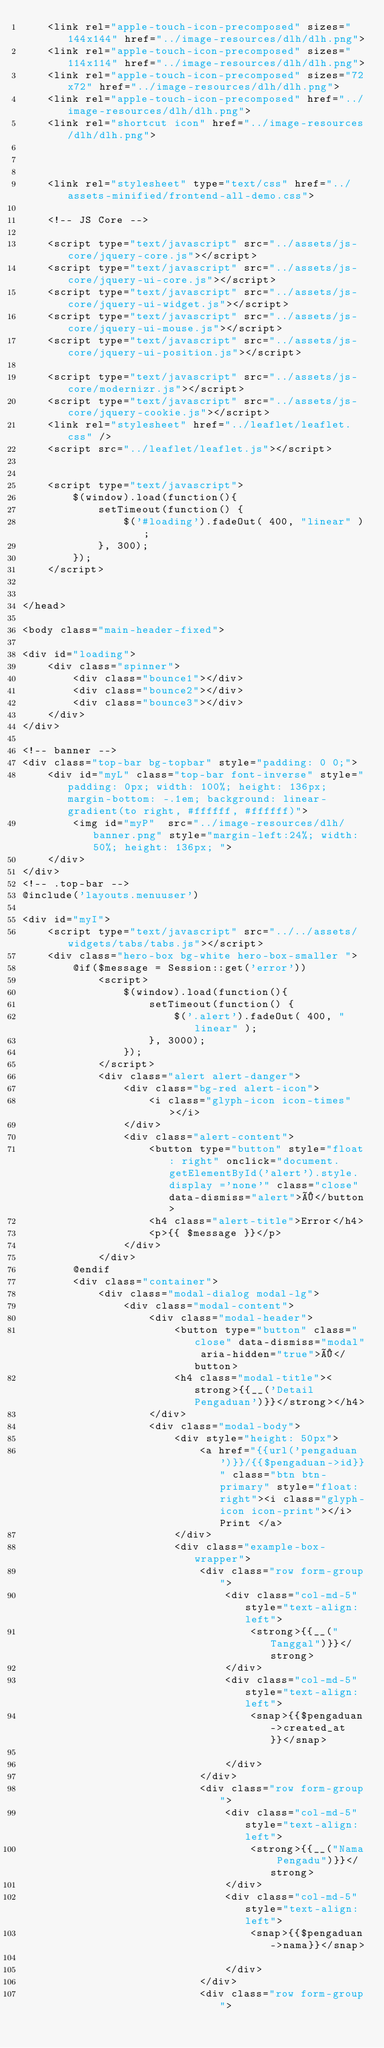<code> <loc_0><loc_0><loc_500><loc_500><_PHP_>    <link rel="apple-touch-icon-precomposed" sizes="144x144" href="../image-resources/dlh/dlh.png">
    <link rel="apple-touch-icon-precomposed" sizes="114x114" href="../image-resources/dlh/dlh.png">
    <link rel="apple-touch-icon-precomposed" sizes="72x72" href="../image-resources/dlh/dlh.png">
    <link rel="apple-touch-icon-precomposed" href="../image-resources/dlh/dlh.png">
    <link rel="shortcut icon" href="../image-resources/dlh/dlh.png">



    <link rel="stylesheet" type="text/css" href="../assets-minified/frontend-all-demo.css">

    <!-- JS Core -->

    <script type="text/javascript" src="../assets/js-core/jquery-core.js"></script>
    <script type="text/javascript" src="../assets/js-core/jquery-ui-core.js"></script>
    <script type="text/javascript" src="../assets/js-core/jquery-ui-widget.js"></script>
    <script type="text/javascript" src="../assets/js-core/jquery-ui-mouse.js"></script>
    <script type="text/javascript" src="../assets/js-core/jquery-ui-position.js"></script>

    <script type="text/javascript" src="../assets/js-core/modernizr.js"></script>
    <script type="text/javascript" src="../assets/js-core/jquery-cookie.js"></script>
    <link rel="stylesheet" href="../leaflet/leaflet.css" />
    <script src="../leaflet/leaflet.js"></script>


    <script type="text/javascript">
        $(window).load(function(){
            setTimeout(function() {
                $('#loading').fadeOut( 400, "linear" );
            }, 300);
        });
    </script>


</head>

<body class="main-header-fixed">

<div id="loading">
    <div class="spinner">
        <div class="bounce1"></div>
        <div class="bounce2"></div>
        <div class="bounce3"></div>
    </div>
</div>

<!-- banner -->
<div class="top-bar bg-topbar" style="padding: 0 0;">
    <div id="myL" class="top-bar font-inverse" style="padding: 0px; width: 100%; height: 136px; margin-bottom: -.1em; background: linear-gradient(to right, #ffffff, #ffffff)">
        <img id="myP"  src="../image-resources/dlh/banner.png" style="margin-left:24%; width: 50%; height: 136px; ">
    </div>
</div>
<!-- .top-bar -->
@include('layouts.menuuser')

<div id="myI">
    <script type="text/javascript" src="../../assets/widgets/tabs/tabs.js"></script>
    <div class="hero-box bg-white hero-box-smaller ">
        @if($message = Session::get('error'))
            <script>
                $(window).load(function(){
                    setTimeout(function() {
                        $('.alert').fadeOut( 400, "linear" );
                    }, 3000);
                });
            </script>
            <div class="alert alert-danger">
                <div class="bg-red alert-icon">
                    <i class="glyph-icon icon-times"></i>
                </div>
                <div class="alert-content">
                    <button type="button" style="float: right" onclick="document.getElementById('alert').style.display ='none'" class="close" data-dismiss="alert">×</button>
                    <h4 class="alert-title">Error</h4>
                    <p>{{ $message }}</p>
                </div>
            </div>
        @endif
        <div class="container">
            <div class="modal-dialog modal-lg">
                <div class="modal-content">
                    <div class="modal-header">
                        <button type="button" class="close" data-dismiss="modal" aria-hidden="true">×</button>
                        <h4 class="modal-title"><strong>{{__('Detail Pengaduan')}}</strong></h4>
                    </div>
                    <div class="modal-body">
                        <div style="height: 50px">
                            <a href="{{url('pengaduan')}}/{{$pengaduan->id}}" class="btn btn-primary" style="float: right"><i class="glyph-icon icon-print"></i> Print </a>
                        </div>
                        <div class="example-box-wrapper">
                            <div class="row form-group">
                                <div class="col-md-5" style="text-align: left">
                                    <strong>{{__("Tanggal")}}</strong>
                                </div>
                                <div class="col-md-5" style="text-align: left">
                                    <snap>{{$pengaduan->created_at}}</snap>

                                </div>
                            </div>
                            <div class="row form-group">
                                <div class="col-md-5" style="text-align: left">
                                    <strong>{{__("Nama Pengadu")}}</strong>
                                </div>
                                <div class="col-md-5" style="text-align: left">
                                    <snap>{{$pengaduan->nama}}</snap>

                                </div>
                            </div>
                            <div class="row form-group"></code> 